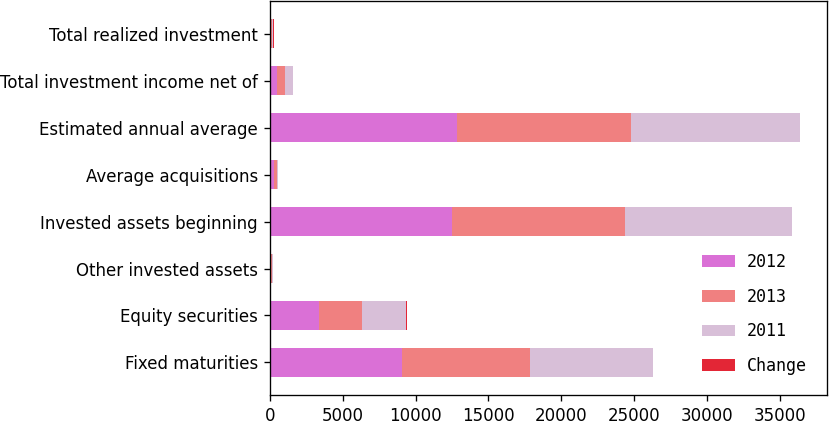<chart> <loc_0><loc_0><loc_500><loc_500><stacked_bar_chart><ecel><fcel>Fixed maturities<fcel>Equity securities<fcel>Other invested assets<fcel>Invested assets beginning<fcel>Average acquisitions<fcel>Estimated annual average<fcel>Total investment income net of<fcel>Total realized investment<nl><fcel>2012<fcel>9093<fcel>3373<fcel>68<fcel>12534<fcel>288<fcel>12822<fcel>529<fcel>83<nl><fcel>2013<fcel>8779<fcel>2956<fcel>66<fcel>11801<fcel>187<fcel>11988<fcel>531<fcel>42<nl><fcel>2011<fcel>8383<fcel>3041<fcel>84<fcel>11508<fcel>64<fcel>11572<fcel>525<fcel>70<nl><fcel>Change<fcel>4<fcel>14<fcel>3<fcel>6<fcel>54<fcel>7<fcel>0<fcel>98<nl></chart> 